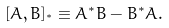<formula> <loc_0><loc_0><loc_500><loc_500>[ A , B ] _ { ^ { * } } \equiv A ^ { * } B - B ^ { * } A .</formula> 